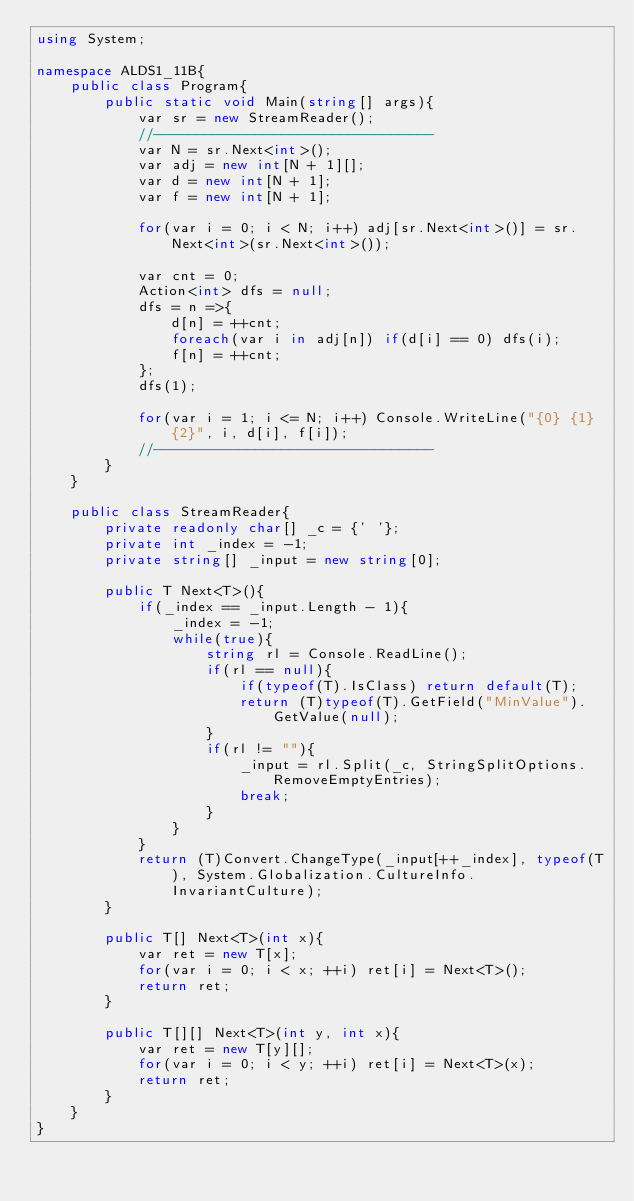Convert code to text. <code><loc_0><loc_0><loc_500><loc_500><_C#_>using System;

namespace ALDS1_11B{
    public class Program{
        public static void Main(string[] args){
            var sr = new StreamReader();
            //---------------------------------
            var N = sr.Next<int>();
            var adj = new int[N + 1][];
            var d = new int[N + 1];
            var f = new int[N + 1];

            for(var i = 0; i < N; i++) adj[sr.Next<int>()] = sr.Next<int>(sr.Next<int>());

            var cnt = 0;
            Action<int> dfs = null;
            dfs = n =>{
                d[n] = ++cnt;
                foreach(var i in adj[n]) if(d[i] == 0) dfs(i);
                f[n] = ++cnt;
            };
            dfs(1);

            for(var i = 1; i <= N; i++) Console.WriteLine("{0} {1} {2}", i, d[i], f[i]);
            //---------------------------------
        }
    }

    public class StreamReader{
        private readonly char[] _c = {' '};
        private int _index = -1;
        private string[] _input = new string[0];

        public T Next<T>(){
            if(_index == _input.Length - 1){
                _index = -1;
                while(true){
                    string rl = Console.ReadLine();
                    if(rl == null){
                        if(typeof(T).IsClass) return default(T);
                        return (T)typeof(T).GetField("MinValue").GetValue(null);
                    }
                    if(rl != ""){
                        _input = rl.Split(_c, StringSplitOptions.RemoveEmptyEntries);
                        break;
                    }
                }
            }
            return (T)Convert.ChangeType(_input[++_index], typeof(T), System.Globalization.CultureInfo.InvariantCulture);
        }

        public T[] Next<T>(int x){
            var ret = new T[x];
            for(var i = 0; i < x; ++i) ret[i] = Next<T>();
            return ret;
        }

        public T[][] Next<T>(int y, int x){
            var ret = new T[y][];
            for(var i = 0; i < y; ++i) ret[i] = Next<T>(x);
            return ret;
        }
    }
}</code> 